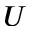Convert formula to latex. <formula><loc_0><loc_0><loc_500><loc_500>U</formula> 